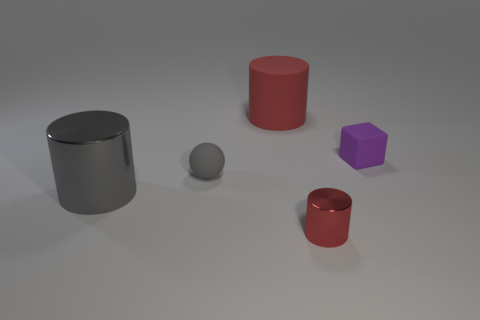How many red cylinders must be subtracted to get 1 red cylinders? 1 Add 1 red metal things. How many objects exist? 6 Subtract all cylinders. How many objects are left? 2 Subtract all cylinders. Subtract all small purple rubber cubes. How many objects are left? 1 Add 2 tiny red objects. How many tiny red objects are left? 3 Add 5 metallic cylinders. How many metallic cylinders exist? 7 Subtract 1 gray balls. How many objects are left? 4 